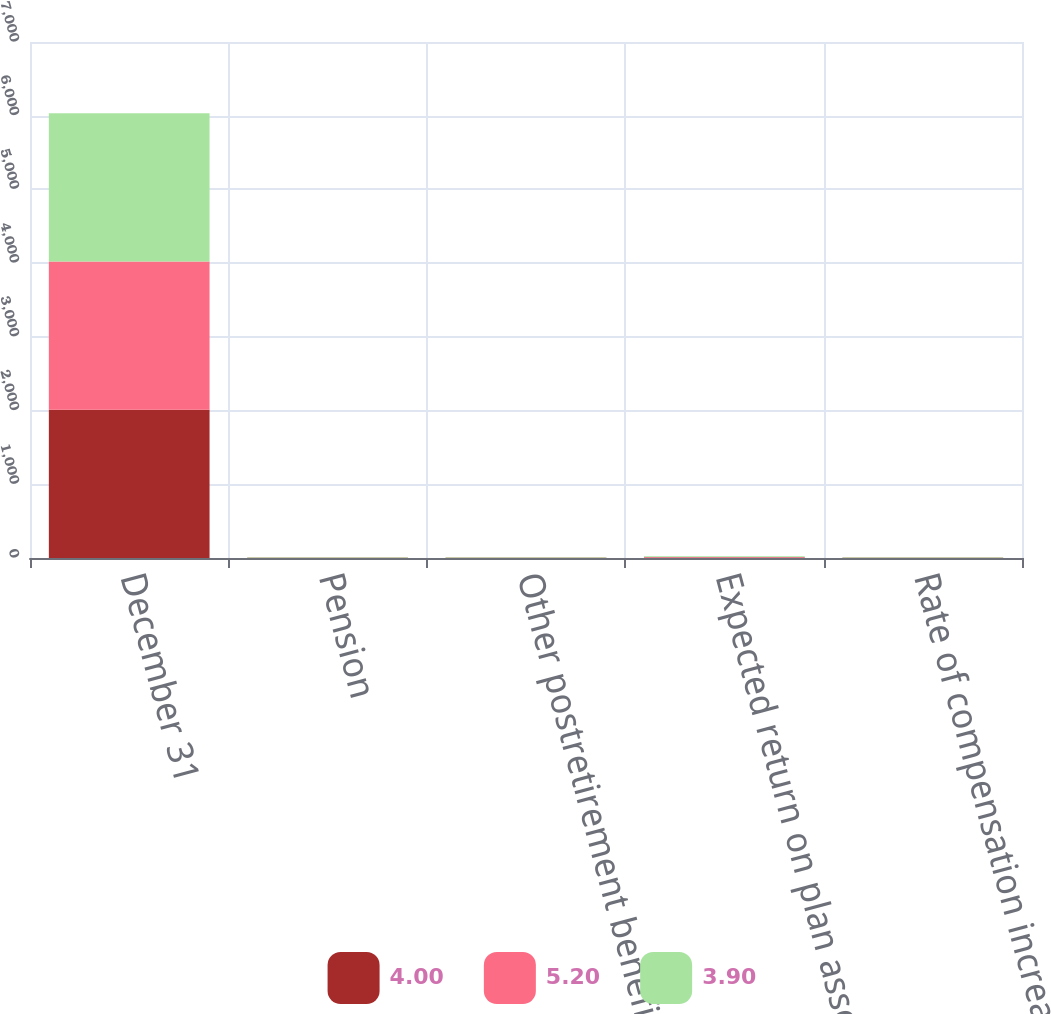Convert chart to OTSL. <chart><loc_0><loc_0><loc_500><loc_500><stacked_bar_chart><ecel><fcel>December 31<fcel>Pension<fcel>Other postretirement benefits<fcel>Expected return on plan assets<fcel>Rate of compensation increase<nl><fcel>4<fcel>2012<fcel>3.8<fcel>3.3<fcel>7.5<fcel>4<nl><fcel>5.2<fcel>2011<fcel>4.4<fcel>4<fcel>7.75<fcel>3.9<nl><fcel>3.9<fcel>2010<fcel>5.3<fcel>4.9<fcel>7.75<fcel>5.2<nl></chart> 